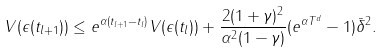<formula> <loc_0><loc_0><loc_500><loc_500>V ( \epsilon ( t _ { l + 1 } ) ) \leq e ^ { \alpha ( t _ { l + 1 } - t _ { l } ) } V ( \epsilon ( t _ { l } ) ) + \frac { 2 ( 1 + \gamma ) ^ { 2 } } { \alpha ^ { 2 } ( 1 - \gamma ) } ( e ^ { \alpha T ^ { d } } - 1 ) \bar { \delta } ^ { 2 } .</formula> 